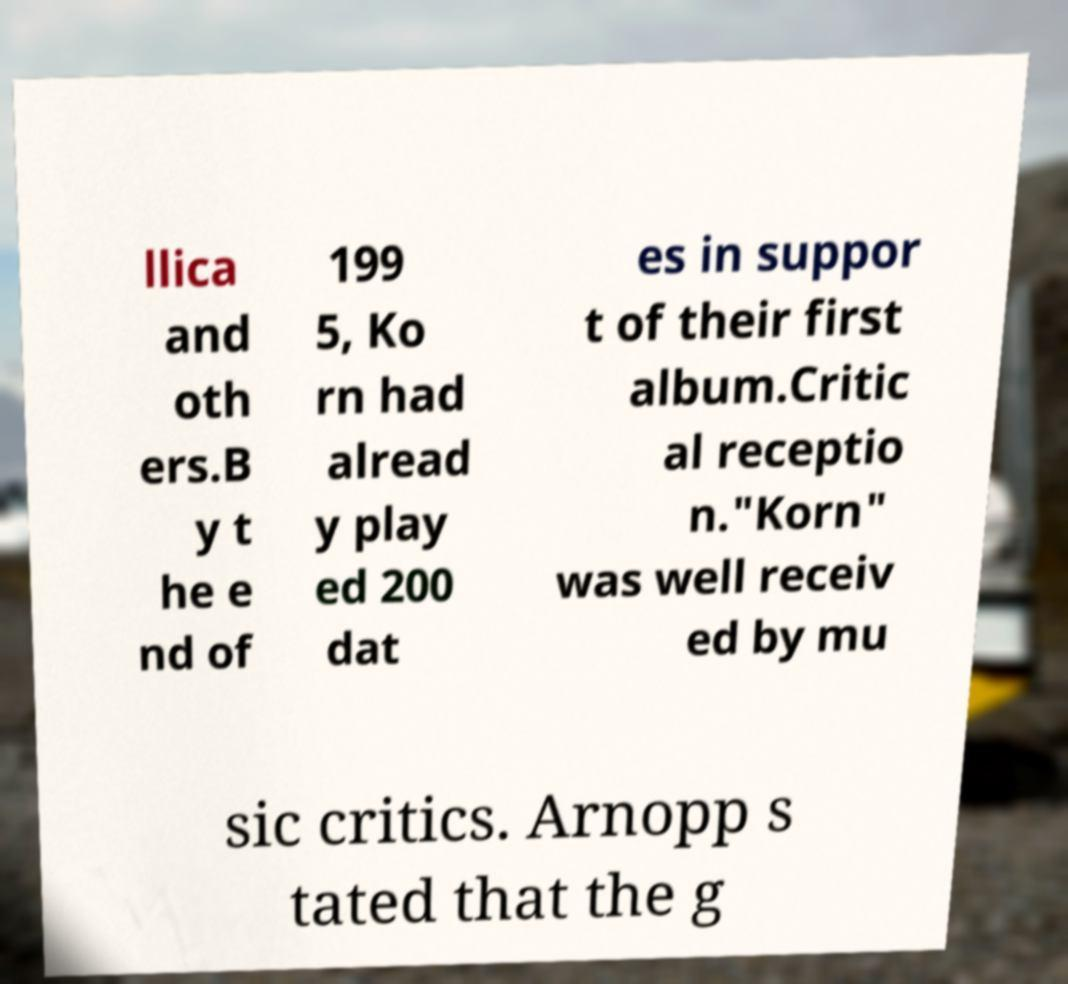Can you read and provide the text displayed in the image?This photo seems to have some interesting text. Can you extract and type it out for me? llica and oth ers.B y t he e nd of 199 5, Ko rn had alread y play ed 200 dat es in suppor t of their first album.Critic al receptio n."Korn" was well receiv ed by mu sic critics. Arnopp s tated that the g 